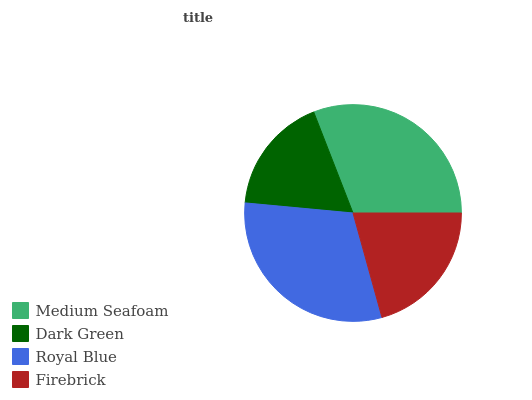Is Dark Green the minimum?
Answer yes or no. Yes. Is Medium Seafoam the maximum?
Answer yes or no. Yes. Is Royal Blue the minimum?
Answer yes or no. No. Is Royal Blue the maximum?
Answer yes or no. No. Is Royal Blue greater than Dark Green?
Answer yes or no. Yes. Is Dark Green less than Royal Blue?
Answer yes or no. Yes. Is Dark Green greater than Royal Blue?
Answer yes or no. No. Is Royal Blue less than Dark Green?
Answer yes or no. No. Is Royal Blue the high median?
Answer yes or no. Yes. Is Firebrick the low median?
Answer yes or no. Yes. Is Firebrick the high median?
Answer yes or no. No. Is Medium Seafoam the low median?
Answer yes or no. No. 